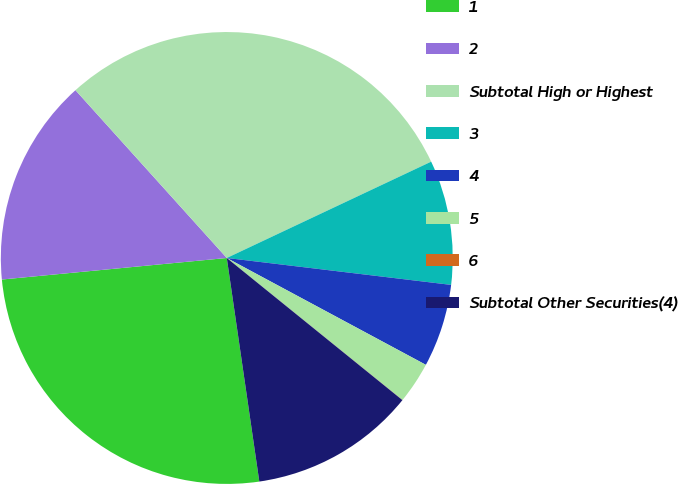Convert chart. <chart><loc_0><loc_0><loc_500><loc_500><pie_chart><fcel>1<fcel>2<fcel>Subtotal High or Highest<fcel>3<fcel>4<fcel>5<fcel>6<fcel>Subtotal Other Securities(4)<nl><fcel>25.78%<fcel>14.84%<fcel>29.67%<fcel>8.91%<fcel>5.94%<fcel>2.98%<fcel>0.01%<fcel>11.87%<nl></chart> 